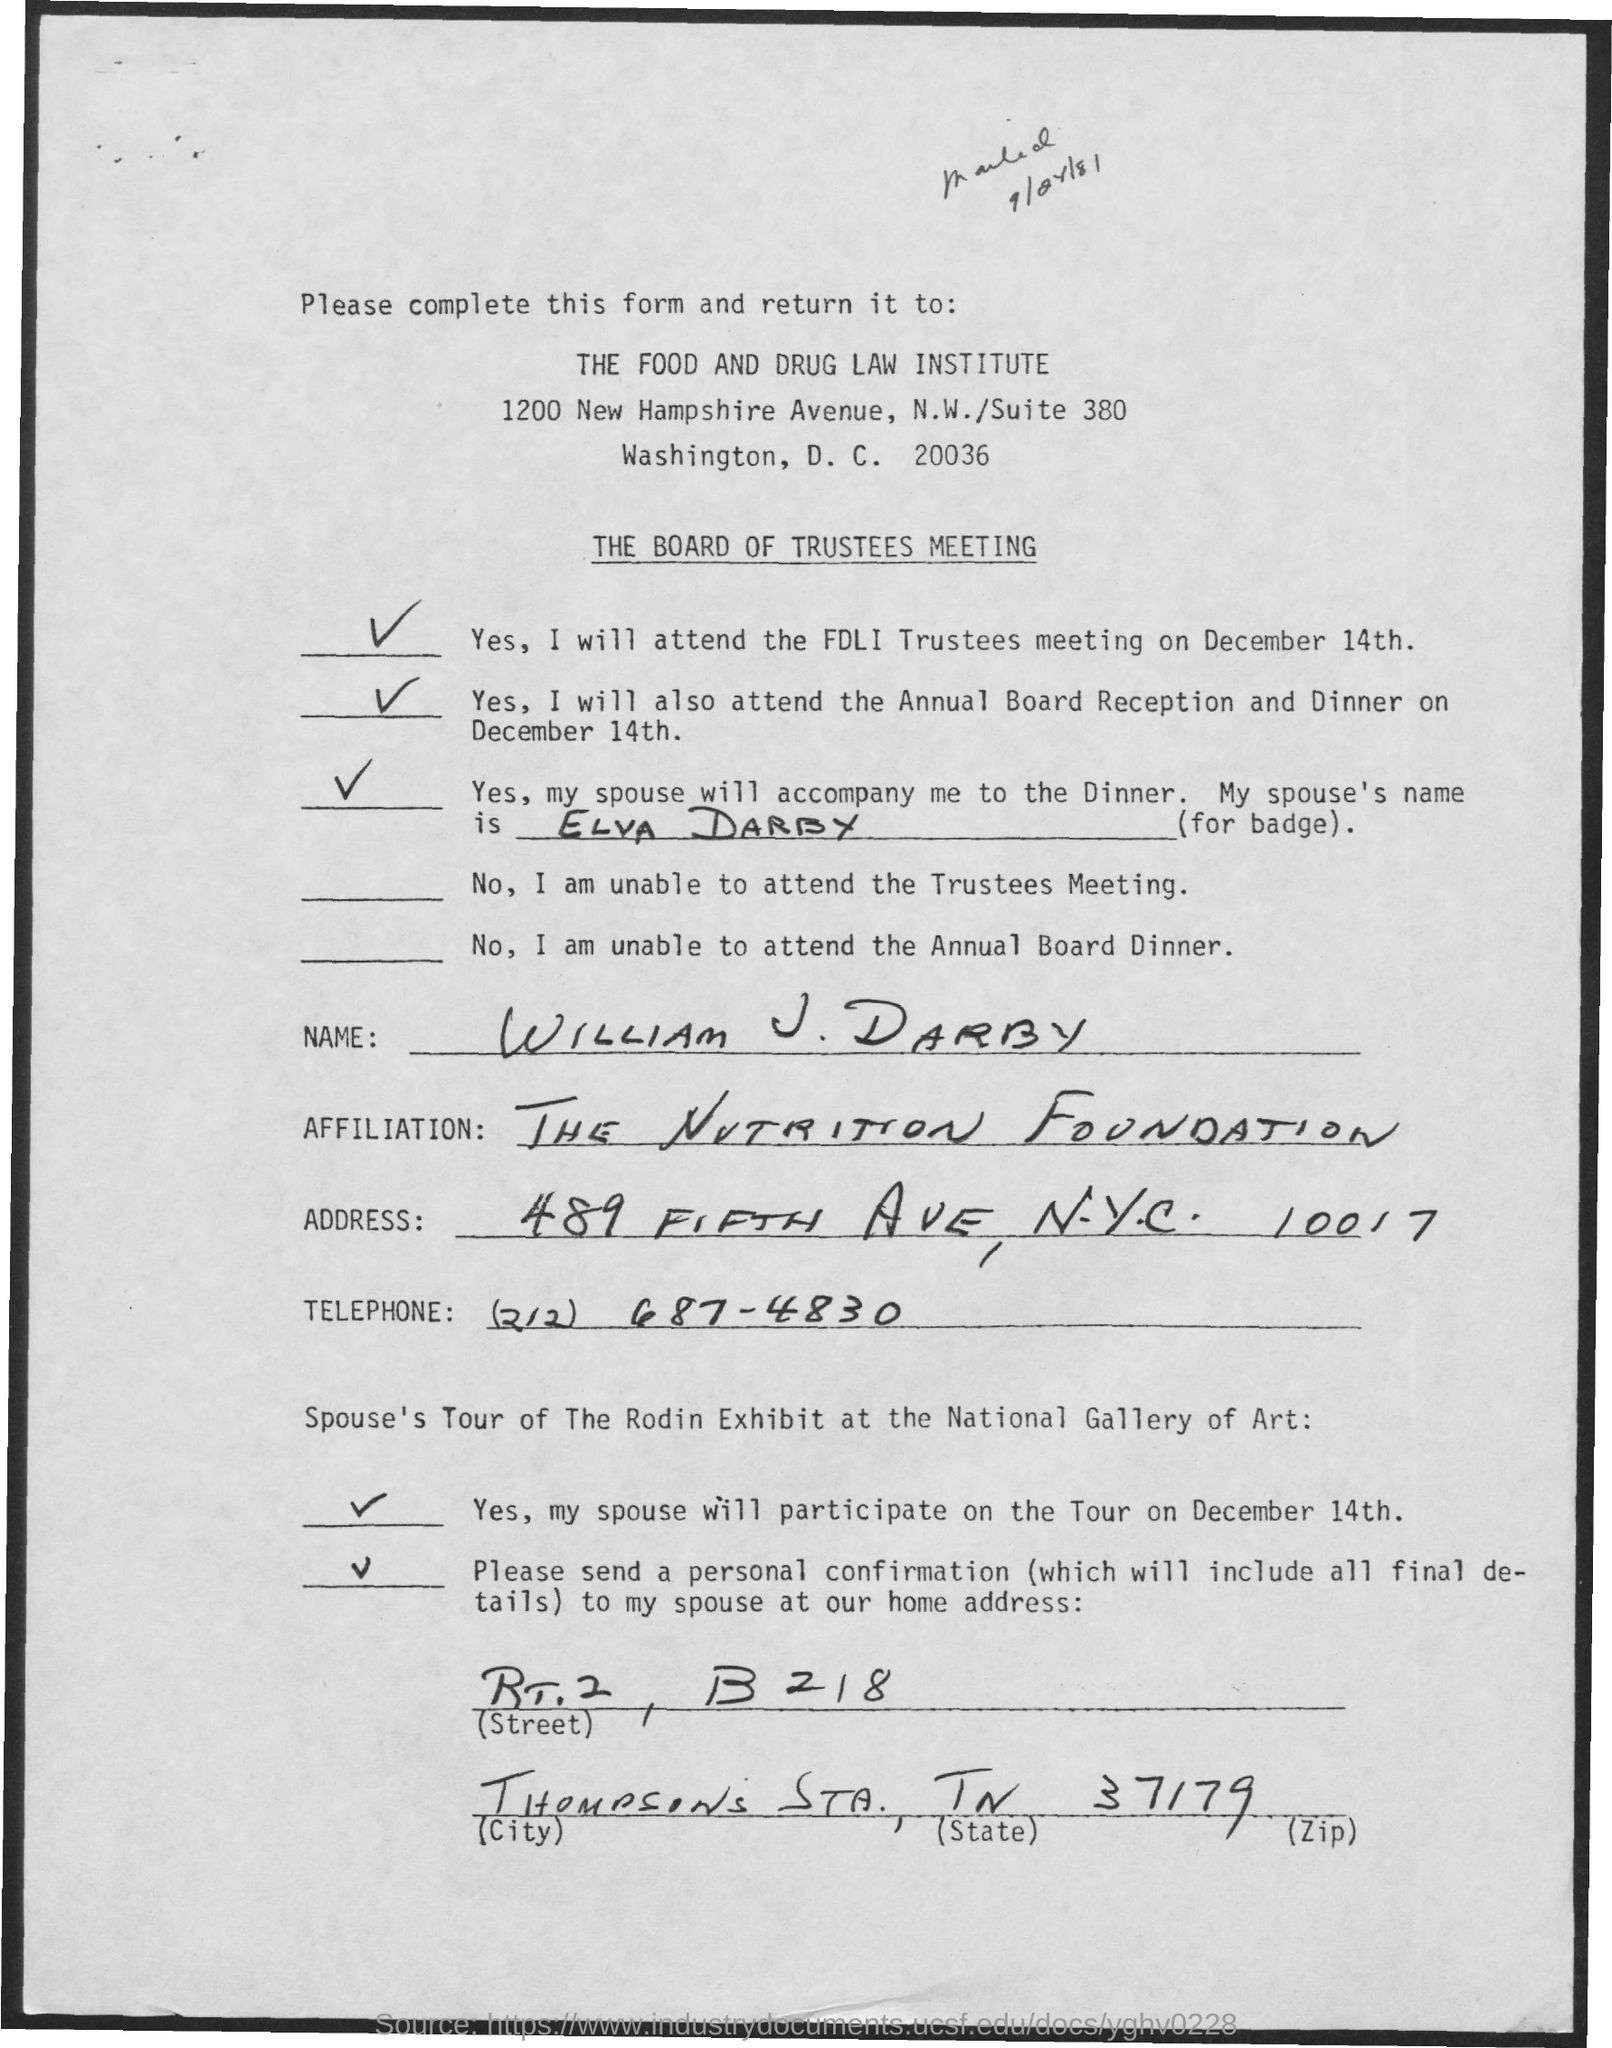Outline some significant characteristics in this image. WILLAM is affiliated with THE NUTRITION FOUNDATION. Please return the form to the Food and Drug Law Institute. The filled form shall be sent to THE FOOD AND DRUG LAW INSTITUTE. William J. Darby was accompanied by Elva Darby. This form is for the Board of Trustees meeting. 